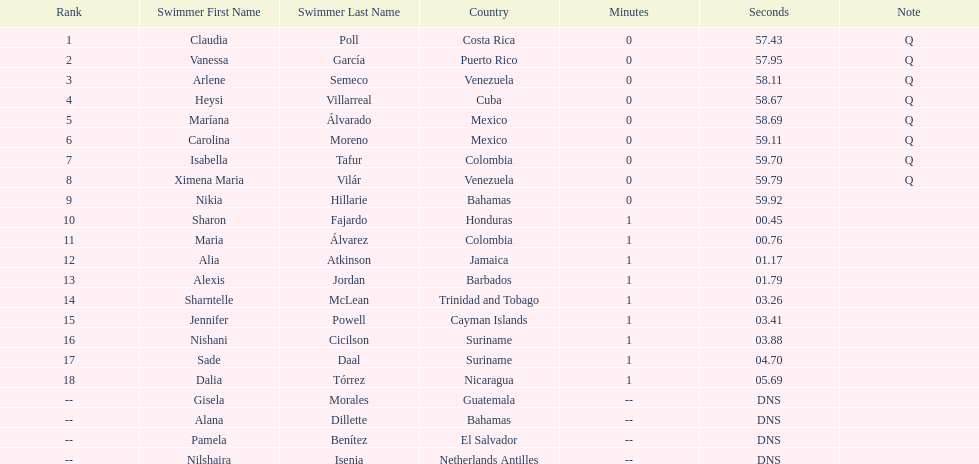What was claudia roll's time? 57.43. 